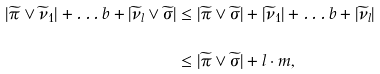<formula> <loc_0><loc_0><loc_500><loc_500>| \widetilde { \pi } \vee \widetilde { \nu } _ { 1 } | + \dots b + | \widetilde { \nu } _ { l } \vee \widetilde { \sigma } | & \leq | \widetilde { \pi } \vee \widetilde { \sigma } | + | \widetilde { \nu } _ { 1 } | + \dots b + | \widetilde { \nu } _ { l } | \\ & \leq | \widetilde { \pi } \vee \widetilde { \sigma } | + l \cdot m ,</formula> 